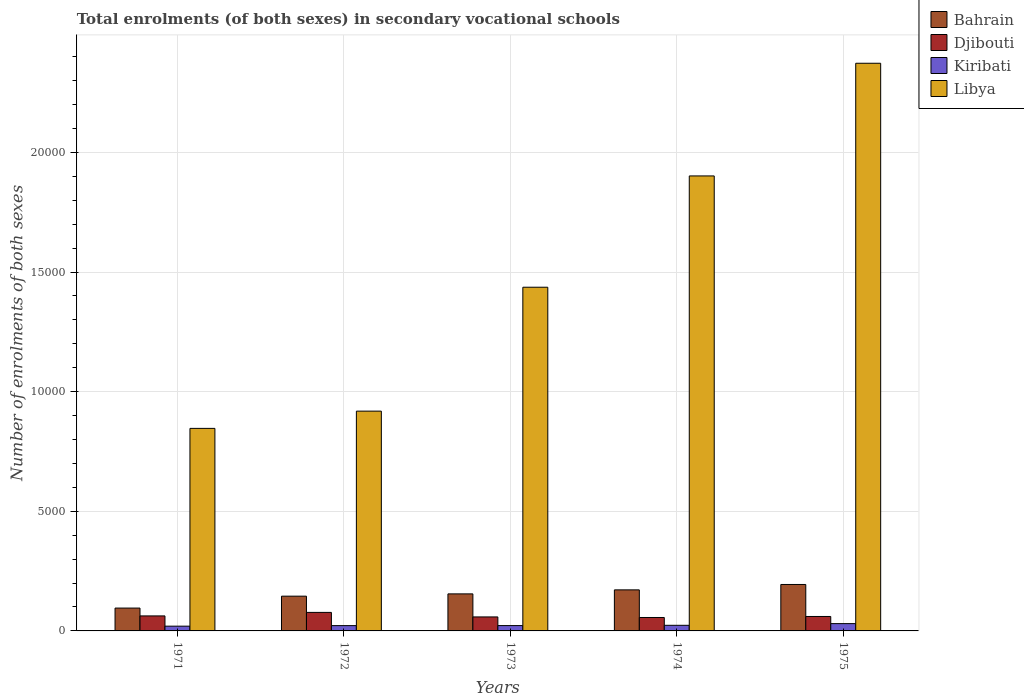How many groups of bars are there?
Provide a short and direct response. 5. Are the number of bars on each tick of the X-axis equal?
Make the answer very short. Yes. How many bars are there on the 4th tick from the right?
Provide a succinct answer. 4. What is the label of the 2nd group of bars from the left?
Provide a short and direct response. 1972. What is the number of enrolments in secondary schools in Djibouti in 1972?
Your response must be concise. 774. Across all years, what is the maximum number of enrolments in secondary schools in Bahrain?
Offer a very short reply. 1941. Across all years, what is the minimum number of enrolments in secondary schools in Djibouti?
Give a very brief answer. 561. In which year was the number of enrolments in secondary schools in Bahrain maximum?
Provide a succinct answer. 1975. In which year was the number of enrolments in secondary schools in Bahrain minimum?
Your answer should be very brief. 1971. What is the total number of enrolments in secondary schools in Libya in the graph?
Make the answer very short. 7.48e+04. What is the difference between the number of enrolments in secondary schools in Libya in 1972 and that in 1973?
Your response must be concise. -5179. What is the difference between the number of enrolments in secondary schools in Libya in 1975 and the number of enrolments in secondary schools in Kiribati in 1974?
Offer a terse response. 2.35e+04. What is the average number of enrolments in secondary schools in Kiribati per year?
Offer a very short reply. 236.8. In the year 1973, what is the difference between the number of enrolments in secondary schools in Djibouti and number of enrolments in secondary schools in Bahrain?
Offer a terse response. -963. What is the ratio of the number of enrolments in secondary schools in Kiribati in 1974 to that in 1975?
Provide a succinct answer. 0.77. Is the number of enrolments in secondary schools in Kiribati in 1971 less than that in 1972?
Provide a short and direct response. Yes. What is the difference between the highest and the second highest number of enrolments in secondary schools in Djibouti?
Your answer should be compact. 147. What is the difference between the highest and the lowest number of enrolments in secondary schools in Djibouti?
Provide a succinct answer. 213. Is it the case that in every year, the sum of the number of enrolments in secondary schools in Bahrain and number of enrolments in secondary schools in Libya is greater than the sum of number of enrolments in secondary schools in Kiribati and number of enrolments in secondary schools in Djibouti?
Provide a succinct answer. Yes. What does the 4th bar from the left in 1973 represents?
Provide a succinct answer. Libya. What does the 2nd bar from the right in 1973 represents?
Make the answer very short. Kiribati. How many bars are there?
Keep it short and to the point. 20. How many years are there in the graph?
Offer a terse response. 5. Are the values on the major ticks of Y-axis written in scientific E-notation?
Give a very brief answer. No. Does the graph contain grids?
Ensure brevity in your answer.  Yes. How many legend labels are there?
Offer a terse response. 4. What is the title of the graph?
Give a very brief answer. Total enrolments (of both sexes) in secondary vocational schools. What is the label or title of the Y-axis?
Provide a succinct answer. Number of enrolments of both sexes. What is the Number of enrolments of both sexes of Bahrain in 1971?
Ensure brevity in your answer.  955. What is the Number of enrolments of both sexes of Djibouti in 1971?
Make the answer very short. 627. What is the Number of enrolments of both sexes of Kiribati in 1971?
Keep it short and to the point. 199. What is the Number of enrolments of both sexes in Libya in 1971?
Offer a very short reply. 8465. What is the Number of enrolments of both sexes of Bahrain in 1972?
Your answer should be very brief. 1453. What is the Number of enrolments of both sexes of Djibouti in 1972?
Provide a short and direct response. 774. What is the Number of enrolments of both sexes in Kiribati in 1972?
Your answer should be compact. 222. What is the Number of enrolments of both sexes in Libya in 1972?
Offer a very short reply. 9186. What is the Number of enrolments of both sexes in Bahrain in 1973?
Your answer should be compact. 1548. What is the Number of enrolments of both sexes of Djibouti in 1973?
Your response must be concise. 585. What is the Number of enrolments of both sexes of Kiribati in 1973?
Give a very brief answer. 223. What is the Number of enrolments of both sexes of Libya in 1973?
Keep it short and to the point. 1.44e+04. What is the Number of enrolments of both sexes in Bahrain in 1974?
Your answer should be very brief. 1716. What is the Number of enrolments of both sexes of Djibouti in 1974?
Offer a terse response. 561. What is the Number of enrolments of both sexes of Kiribati in 1974?
Offer a very short reply. 235. What is the Number of enrolments of both sexes in Libya in 1974?
Offer a very short reply. 1.90e+04. What is the Number of enrolments of both sexes in Bahrain in 1975?
Your answer should be compact. 1941. What is the Number of enrolments of both sexes in Djibouti in 1975?
Make the answer very short. 604. What is the Number of enrolments of both sexes in Kiribati in 1975?
Make the answer very short. 305. What is the Number of enrolments of both sexes of Libya in 1975?
Make the answer very short. 2.37e+04. Across all years, what is the maximum Number of enrolments of both sexes of Bahrain?
Your answer should be compact. 1941. Across all years, what is the maximum Number of enrolments of both sexes in Djibouti?
Offer a very short reply. 774. Across all years, what is the maximum Number of enrolments of both sexes of Kiribati?
Your answer should be compact. 305. Across all years, what is the maximum Number of enrolments of both sexes in Libya?
Keep it short and to the point. 2.37e+04. Across all years, what is the minimum Number of enrolments of both sexes of Bahrain?
Provide a short and direct response. 955. Across all years, what is the minimum Number of enrolments of both sexes of Djibouti?
Keep it short and to the point. 561. Across all years, what is the minimum Number of enrolments of both sexes of Kiribati?
Your response must be concise. 199. Across all years, what is the minimum Number of enrolments of both sexes in Libya?
Provide a succinct answer. 8465. What is the total Number of enrolments of both sexes in Bahrain in the graph?
Your response must be concise. 7613. What is the total Number of enrolments of both sexes of Djibouti in the graph?
Ensure brevity in your answer.  3151. What is the total Number of enrolments of both sexes of Kiribati in the graph?
Your answer should be compact. 1184. What is the total Number of enrolments of both sexes of Libya in the graph?
Your answer should be compact. 7.48e+04. What is the difference between the Number of enrolments of both sexes of Bahrain in 1971 and that in 1972?
Ensure brevity in your answer.  -498. What is the difference between the Number of enrolments of both sexes in Djibouti in 1971 and that in 1972?
Provide a short and direct response. -147. What is the difference between the Number of enrolments of both sexes in Libya in 1971 and that in 1972?
Your answer should be very brief. -721. What is the difference between the Number of enrolments of both sexes in Bahrain in 1971 and that in 1973?
Your answer should be very brief. -593. What is the difference between the Number of enrolments of both sexes of Djibouti in 1971 and that in 1973?
Ensure brevity in your answer.  42. What is the difference between the Number of enrolments of both sexes in Kiribati in 1971 and that in 1973?
Provide a succinct answer. -24. What is the difference between the Number of enrolments of both sexes in Libya in 1971 and that in 1973?
Offer a very short reply. -5900. What is the difference between the Number of enrolments of both sexes in Bahrain in 1971 and that in 1974?
Offer a very short reply. -761. What is the difference between the Number of enrolments of both sexes in Kiribati in 1971 and that in 1974?
Give a very brief answer. -36. What is the difference between the Number of enrolments of both sexes of Libya in 1971 and that in 1974?
Your answer should be very brief. -1.06e+04. What is the difference between the Number of enrolments of both sexes in Bahrain in 1971 and that in 1975?
Your answer should be compact. -986. What is the difference between the Number of enrolments of both sexes of Djibouti in 1971 and that in 1975?
Make the answer very short. 23. What is the difference between the Number of enrolments of both sexes in Kiribati in 1971 and that in 1975?
Provide a short and direct response. -106. What is the difference between the Number of enrolments of both sexes in Libya in 1971 and that in 1975?
Offer a terse response. -1.53e+04. What is the difference between the Number of enrolments of both sexes of Bahrain in 1972 and that in 1973?
Your answer should be very brief. -95. What is the difference between the Number of enrolments of both sexes in Djibouti in 1972 and that in 1973?
Keep it short and to the point. 189. What is the difference between the Number of enrolments of both sexes of Libya in 1972 and that in 1973?
Keep it short and to the point. -5179. What is the difference between the Number of enrolments of both sexes in Bahrain in 1972 and that in 1974?
Offer a terse response. -263. What is the difference between the Number of enrolments of both sexes of Djibouti in 1972 and that in 1974?
Ensure brevity in your answer.  213. What is the difference between the Number of enrolments of both sexes of Libya in 1972 and that in 1974?
Give a very brief answer. -9831. What is the difference between the Number of enrolments of both sexes in Bahrain in 1972 and that in 1975?
Make the answer very short. -488. What is the difference between the Number of enrolments of both sexes of Djibouti in 1972 and that in 1975?
Make the answer very short. 170. What is the difference between the Number of enrolments of both sexes of Kiribati in 1972 and that in 1975?
Ensure brevity in your answer.  -83. What is the difference between the Number of enrolments of both sexes of Libya in 1972 and that in 1975?
Provide a short and direct response. -1.45e+04. What is the difference between the Number of enrolments of both sexes in Bahrain in 1973 and that in 1974?
Provide a succinct answer. -168. What is the difference between the Number of enrolments of both sexes in Libya in 1973 and that in 1974?
Your response must be concise. -4652. What is the difference between the Number of enrolments of both sexes in Bahrain in 1973 and that in 1975?
Offer a terse response. -393. What is the difference between the Number of enrolments of both sexes in Kiribati in 1973 and that in 1975?
Offer a terse response. -82. What is the difference between the Number of enrolments of both sexes in Libya in 1973 and that in 1975?
Give a very brief answer. -9361. What is the difference between the Number of enrolments of both sexes in Bahrain in 1974 and that in 1975?
Offer a terse response. -225. What is the difference between the Number of enrolments of both sexes in Djibouti in 1974 and that in 1975?
Your answer should be very brief. -43. What is the difference between the Number of enrolments of both sexes in Kiribati in 1974 and that in 1975?
Keep it short and to the point. -70. What is the difference between the Number of enrolments of both sexes of Libya in 1974 and that in 1975?
Provide a succinct answer. -4709. What is the difference between the Number of enrolments of both sexes of Bahrain in 1971 and the Number of enrolments of both sexes of Djibouti in 1972?
Provide a short and direct response. 181. What is the difference between the Number of enrolments of both sexes in Bahrain in 1971 and the Number of enrolments of both sexes in Kiribati in 1972?
Offer a terse response. 733. What is the difference between the Number of enrolments of both sexes of Bahrain in 1971 and the Number of enrolments of both sexes of Libya in 1972?
Your answer should be very brief. -8231. What is the difference between the Number of enrolments of both sexes in Djibouti in 1971 and the Number of enrolments of both sexes in Kiribati in 1972?
Your answer should be compact. 405. What is the difference between the Number of enrolments of both sexes in Djibouti in 1971 and the Number of enrolments of both sexes in Libya in 1972?
Keep it short and to the point. -8559. What is the difference between the Number of enrolments of both sexes in Kiribati in 1971 and the Number of enrolments of both sexes in Libya in 1972?
Your response must be concise. -8987. What is the difference between the Number of enrolments of both sexes of Bahrain in 1971 and the Number of enrolments of both sexes of Djibouti in 1973?
Your response must be concise. 370. What is the difference between the Number of enrolments of both sexes in Bahrain in 1971 and the Number of enrolments of both sexes in Kiribati in 1973?
Your answer should be compact. 732. What is the difference between the Number of enrolments of both sexes of Bahrain in 1971 and the Number of enrolments of both sexes of Libya in 1973?
Your response must be concise. -1.34e+04. What is the difference between the Number of enrolments of both sexes in Djibouti in 1971 and the Number of enrolments of both sexes in Kiribati in 1973?
Your answer should be very brief. 404. What is the difference between the Number of enrolments of both sexes of Djibouti in 1971 and the Number of enrolments of both sexes of Libya in 1973?
Make the answer very short. -1.37e+04. What is the difference between the Number of enrolments of both sexes in Kiribati in 1971 and the Number of enrolments of both sexes in Libya in 1973?
Make the answer very short. -1.42e+04. What is the difference between the Number of enrolments of both sexes of Bahrain in 1971 and the Number of enrolments of both sexes of Djibouti in 1974?
Provide a short and direct response. 394. What is the difference between the Number of enrolments of both sexes in Bahrain in 1971 and the Number of enrolments of both sexes in Kiribati in 1974?
Your response must be concise. 720. What is the difference between the Number of enrolments of both sexes in Bahrain in 1971 and the Number of enrolments of both sexes in Libya in 1974?
Offer a terse response. -1.81e+04. What is the difference between the Number of enrolments of both sexes in Djibouti in 1971 and the Number of enrolments of both sexes in Kiribati in 1974?
Your answer should be very brief. 392. What is the difference between the Number of enrolments of both sexes in Djibouti in 1971 and the Number of enrolments of both sexes in Libya in 1974?
Keep it short and to the point. -1.84e+04. What is the difference between the Number of enrolments of both sexes in Kiribati in 1971 and the Number of enrolments of both sexes in Libya in 1974?
Your answer should be very brief. -1.88e+04. What is the difference between the Number of enrolments of both sexes of Bahrain in 1971 and the Number of enrolments of both sexes of Djibouti in 1975?
Ensure brevity in your answer.  351. What is the difference between the Number of enrolments of both sexes of Bahrain in 1971 and the Number of enrolments of both sexes of Kiribati in 1975?
Offer a terse response. 650. What is the difference between the Number of enrolments of both sexes in Bahrain in 1971 and the Number of enrolments of both sexes in Libya in 1975?
Provide a succinct answer. -2.28e+04. What is the difference between the Number of enrolments of both sexes in Djibouti in 1971 and the Number of enrolments of both sexes in Kiribati in 1975?
Provide a short and direct response. 322. What is the difference between the Number of enrolments of both sexes of Djibouti in 1971 and the Number of enrolments of both sexes of Libya in 1975?
Provide a succinct answer. -2.31e+04. What is the difference between the Number of enrolments of both sexes in Kiribati in 1971 and the Number of enrolments of both sexes in Libya in 1975?
Ensure brevity in your answer.  -2.35e+04. What is the difference between the Number of enrolments of both sexes in Bahrain in 1972 and the Number of enrolments of both sexes in Djibouti in 1973?
Provide a short and direct response. 868. What is the difference between the Number of enrolments of both sexes of Bahrain in 1972 and the Number of enrolments of both sexes of Kiribati in 1973?
Your response must be concise. 1230. What is the difference between the Number of enrolments of both sexes of Bahrain in 1972 and the Number of enrolments of both sexes of Libya in 1973?
Give a very brief answer. -1.29e+04. What is the difference between the Number of enrolments of both sexes of Djibouti in 1972 and the Number of enrolments of both sexes of Kiribati in 1973?
Offer a very short reply. 551. What is the difference between the Number of enrolments of both sexes in Djibouti in 1972 and the Number of enrolments of both sexes in Libya in 1973?
Provide a succinct answer. -1.36e+04. What is the difference between the Number of enrolments of both sexes in Kiribati in 1972 and the Number of enrolments of both sexes in Libya in 1973?
Your answer should be very brief. -1.41e+04. What is the difference between the Number of enrolments of both sexes of Bahrain in 1972 and the Number of enrolments of both sexes of Djibouti in 1974?
Give a very brief answer. 892. What is the difference between the Number of enrolments of both sexes in Bahrain in 1972 and the Number of enrolments of both sexes in Kiribati in 1974?
Keep it short and to the point. 1218. What is the difference between the Number of enrolments of both sexes in Bahrain in 1972 and the Number of enrolments of both sexes in Libya in 1974?
Keep it short and to the point. -1.76e+04. What is the difference between the Number of enrolments of both sexes of Djibouti in 1972 and the Number of enrolments of both sexes of Kiribati in 1974?
Your answer should be very brief. 539. What is the difference between the Number of enrolments of both sexes of Djibouti in 1972 and the Number of enrolments of both sexes of Libya in 1974?
Your answer should be very brief. -1.82e+04. What is the difference between the Number of enrolments of both sexes in Kiribati in 1972 and the Number of enrolments of both sexes in Libya in 1974?
Give a very brief answer. -1.88e+04. What is the difference between the Number of enrolments of both sexes of Bahrain in 1972 and the Number of enrolments of both sexes of Djibouti in 1975?
Make the answer very short. 849. What is the difference between the Number of enrolments of both sexes of Bahrain in 1972 and the Number of enrolments of both sexes of Kiribati in 1975?
Give a very brief answer. 1148. What is the difference between the Number of enrolments of both sexes of Bahrain in 1972 and the Number of enrolments of both sexes of Libya in 1975?
Your answer should be compact. -2.23e+04. What is the difference between the Number of enrolments of both sexes in Djibouti in 1972 and the Number of enrolments of both sexes in Kiribati in 1975?
Provide a succinct answer. 469. What is the difference between the Number of enrolments of both sexes in Djibouti in 1972 and the Number of enrolments of both sexes in Libya in 1975?
Your answer should be very brief. -2.30e+04. What is the difference between the Number of enrolments of both sexes in Kiribati in 1972 and the Number of enrolments of both sexes in Libya in 1975?
Your answer should be very brief. -2.35e+04. What is the difference between the Number of enrolments of both sexes of Bahrain in 1973 and the Number of enrolments of both sexes of Djibouti in 1974?
Keep it short and to the point. 987. What is the difference between the Number of enrolments of both sexes of Bahrain in 1973 and the Number of enrolments of both sexes of Kiribati in 1974?
Provide a succinct answer. 1313. What is the difference between the Number of enrolments of both sexes in Bahrain in 1973 and the Number of enrolments of both sexes in Libya in 1974?
Your answer should be very brief. -1.75e+04. What is the difference between the Number of enrolments of both sexes in Djibouti in 1973 and the Number of enrolments of both sexes in Kiribati in 1974?
Ensure brevity in your answer.  350. What is the difference between the Number of enrolments of both sexes in Djibouti in 1973 and the Number of enrolments of both sexes in Libya in 1974?
Keep it short and to the point. -1.84e+04. What is the difference between the Number of enrolments of both sexes of Kiribati in 1973 and the Number of enrolments of both sexes of Libya in 1974?
Your answer should be very brief. -1.88e+04. What is the difference between the Number of enrolments of both sexes in Bahrain in 1973 and the Number of enrolments of both sexes in Djibouti in 1975?
Give a very brief answer. 944. What is the difference between the Number of enrolments of both sexes in Bahrain in 1973 and the Number of enrolments of both sexes in Kiribati in 1975?
Your answer should be compact. 1243. What is the difference between the Number of enrolments of both sexes in Bahrain in 1973 and the Number of enrolments of both sexes in Libya in 1975?
Your answer should be very brief. -2.22e+04. What is the difference between the Number of enrolments of both sexes in Djibouti in 1973 and the Number of enrolments of both sexes in Kiribati in 1975?
Offer a terse response. 280. What is the difference between the Number of enrolments of both sexes in Djibouti in 1973 and the Number of enrolments of both sexes in Libya in 1975?
Provide a succinct answer. -2.31e+04. What is the difference between the Number of enrolments of both sexes of Kiribati in 1973 and the Number of enrolments of both sexes of Libya in 1975?
Offer a very short reply. -2.35e+04. What is the difference between the Number of enrolments of both sexes of Bahrain in 1974 and the Number of enrolments of both sexes of Djibouti in 1975?
Give a very brief answer. 1112. What is the difference between the Number of enrolments of both sexes of Bahrain in 1974 and the Number of enrolments of both sexes of Kiribati in 1975?
Keep it short and to the point. 1411. What is the difference between the Number of enrolments of both sexes of Bahrain in 1974 and the Number of enrolments of both sexes of Libya in 1975?
Make the answer very short. -2.20e+04. What is the difference between the Number of enrolments of both sexes of Djibouti in 1974 and the Number of enrolments of both sexes of Kiribati in 1975?
Provide a succinct answer. 256. What is the difference between the Number of enrolments of both sexes of Djibouti in 1974 and the Number of enrolments of both sexes of Libya in 1975?
Make the answer very short. -2.32e+04. What is the difference between the Number of enrolments of both sexes in Kiribati in 1974 and the Number of enrolments of both sexes in Libya in 1975?
Your answer should be very brief. -2.35e+04. What is the average Number of enrolments of both sexes of Bahrain per year?
Offer a terse response. 1522.6. What is the average Number of enrolments of both sexes in Djibouti per year?
Keep it short and to the point. 630.2. What is the average Number of enrolments of both sexes in Kiribati per year?
Ensure brevity in your answer.  236.8. What is the average Number of enrolments of both sexes of Libya per year?
Your answer should be very brief. 1.50e+04. In the year 1971, what is the difference between the Number of enrolments of both sexes in Bahrain and Number of enrolments of both sexes in Djibouti?
Make the answer very short. 328. In the year 1971, what is the difference between the Number of enrolments of both sexes in Bahrain and Number of enrolments of both sexes in Kiribati?
Keep it short and to the point. 756. In the year 1971, what is the difference between the Number of enrolments of both sexes of Bahrain and Number of enrolments of both sexes of Libya?
Offer a very short reply. -7510. In the year 1971, what is the difference between the Number of enrolments of both sexes in Djibouti and Number of enrolments of both sexes in Kiribati?
Provide a succinct answer. 428. In the year 1971, what is the difference between the Number of enrolments of both sexes of Djibouti and Number of enrolments of both sexes of Libya?
Keep it short and to the point. -7838. In the year 1971, what is the difference between the Number of enrolments of both sexes of Kiribati and Number of enrolments of both sexes of Libya?
Make the answer very short. -8266. In the year 1972, what is the difference between the Number of enrolments of both sexes of Bahrain and Number of enrolments of both sexes of Djibouti?
Provide a short and direct response. 679. In the year 1972, what is the difference between the Number of enrolments of both sexes of Bahrain and Number of enrolments of both sexes of Kiribati?
Your answer should be very brief. 1231. In the year 1972, what is the difference between the Number of enrolments of both sexes of Bahrain and Number of enrolments of both sexes of Libya?
Keep it short and to the point. -7733. In the year 1972, what is the difference between the Number of enrolments of both sexes in Djibouti and Number of enrolments of both sexes in Kiribati?
Ensure brevity in your answer.  552. In the year 1972, what is the difference between the Number of enrolments of both sexes in Djibouti and Number of enrolments of both sexes in Libya?
Your response must be concise. -8412. In the year 1972, what is the difference between the Number of enrolments of both sexes in Kiribati and Number of enrolments of both sexes in Libya?
Make the answer very short. -8964. In the year 1973, what is the difference between the Number of enrolments of both sexes of Bahrain and Number of enrolments of both sexes of Djibouti?
Ensure brevity in your answer.  963. In the year 1973, what is the difference between the Number of enrolments of both sexes of Bahrain and Number of enrolments of both sexes of Kiribati?
Provide a succinct answer. 1325. In the year 1973, what is the difference between the Number of enrolments of both sexes of Bahrain and Number of enrolments of both sexes of Libya?
Provide a succinct answer. -1.28e+04. In the year 1973, what is the difference between the Number of enrolments of both sexes in Djibouti and Number of enrolments of both sexes in Kiribati?
Offer a terse response. 362. In the year 1973, what is the difference between the Number of enrolments of both sexes in Djibouti and Number of enrolments of both sexes in Libya?
Your response must be concise. -1.38e+04. In the year 1973, what is the difference between the Number of enrolments of both sexes of Kiribati and Number of enrolments of both sexes of Libya?
Give a very brief answer. -1.41e+04. In the year 1974, what is the difference between the Number of enrolments of both sexes in Bahrain and Number of enrolments of both sexes in Djibouti?
Your answer should be compact. 1155. In the year 1974, what is the difference between the Number of enrolments of both sexes of Bahrain and Number of enrolments of both sexes of Kiribati?
Provide a short and direct response. 1481. In the year 1974, what is the difference between the Number of enrolments of both sexes of Bahrain and Number of enrolments of both sexes of Libya?
Give a very brief answer. -1.73e+04. In the year 1974, what is the difference between the Number of enrolments of both sexes of Djibouti and Number of enrolments of both sexes of Kiribati?
Offer a very short reply. 326. In the year 1974, what is the difference between the Number of enrolments of both sexes in Djibouti and Number of enrolments of both sexes in Libya?
Ensure brevity in your answer.  -1.85e+04. In the year 1974, what is the difference between the Number of enrolments of both sexes in Kiribati and Number of enrolments of both sexes in Libya?
Your answer should be very brief. -1.88e+04. In the year 1975, what is the difference between the Number of enrolments of both sexes in Bahrain and Number of enrolments of both sexes in Djibouti?
Provide a succinct answer. 1337. In the year 1975, what is the difference between the Number of enrolments of both sexes of Bahrain and Number of enrolments of both sexes of Kiribati?
Give a very brief answer. 1636. In the year 1975, what is the difference between the Number of enrolments of both sexes of Bahrain and Number of enrolments of both sexes of Libya?
Your response must be concise. -2.18e+04. In the year 1975, what is the difference between the Number of enrolments of both sexes of Djibouti and Number of enrolments of both sexes of Kiribati?
Provide a short and direct response. 299. In the year 1975, what is the difference between the Number of enrolments of both sexes of Djibouti and Number of enrolments of both sexes of Libya?
Your answer should be compact. -2.31e+04. In the year 1975, what is the difference between the Number of enrolments of both sexes of Kiribati and Number of enrolments of both sexes of Libya?
Give a very brief answer. -2.34e+04. What is the ratio of the Number of enrolments of both sexes in Bahrain in 1971 to that in 1972?
Your answer should be compact. 0.66. What is the ratio of the Number of enrolments of both sexes in Djibouti in 1971 to that in 1972?
Give a very brief answer. 0.81. What is the ratio of the Number of enrolments of both sexes in Kiribati in 1971 to that in 1972?
Offer a very short reply. 0.9. What is the ratio of the Number of enrolments of both sexes in Libya in 1971 to that in 1972?
Your answer should be very brief. 0.92. What is the ratio of the Number of enrolments of both sexes in Bahrain in 1971 to that in 1973?
Provide a short and direct response. 0.62. What is the ratio of the Number of enrolments of both sexes in Djibouti in 1971 to that in 1973?
Offer a very short reply. 1.07. What is the ratio of the Number of enrolments of both sexes of Kiribati in 1971 to that in 1973?
Ensure brevity in your answer.  0.89. What is the ratio of the Number of enrolments of both sexes in Libya in 1971 to that in 1973?
Offer a very short reply. 0.59. What is the ratio of the Number of enrolments of both sexes of Bahrain in 1971 to that in 1974?
Your response must be concise. 0.56. What is the ratio of the Number of enrolments of both sexes in Djibouti in 1971 to that in 1974?
Provide a short and direct response. 1.12. What is the ratio of the Number of enrolments of both sexes of Kiribati in 1971 to that in 1974?
Your answer should be compact. 0.85. What is the ratio of the Number of enrolments of both sexes in Libya in 1971 to that in 1974?
Your response must be concise. 0.45. What is the ratio of the Number of enrolments of both sexes in Bahrain in 1971 to that in 1975?
Your answer should be very brief. 0.49. What is the ratio of the Number of enrolments of both sexes of Djibouti in 1971 to that in 1975?
Offer a terse response. 1.04. What is the ratio of the Number of enrolments of both sexes of Kiribati in 1971 to that in 1975?
Your answer should be very brief. 0.65. What is the ratio of the Number of enrolments of both sexes in Libya in 1971 to that in 1975?
Offer a very short reply. 0.36. What is the ratio of the Number of enrolments of both sexes in Bahrain in 1972 to that in 1973?
Make the answer very short. 0.94. What is the ratio of the Number of enrolments of both sexes of Djibouti in 1972 to that in 1973?
Offer a terse response. 1.32. What is the ratio of the Number of enrolments of both sexes in Libya in 1972 to that in 1973?
Your answer should be compact. 0.64. What is the ratio of the Number of enrolments of both sexes of Bahrain in 1972 to that in 1974?
Keep it short and to the point. 0.85. What is the ratio of the Number of enrolments of both sexes of Djibouti in 1972 to that in 1974?
Give a very brief answer. 1.38. What is the ratio of the Number of enrolments of both sexes of Kiribati in 1972 to that in 1974?
Offer a very short reply. 0.94. What is the ratio of the Number of enrolments of both sexes of Libya in 1972 to that in 1974?
Make the answer very short. 0.48. What is the ratio of the Number of enrolments of both sexes of Bahrain in 1972 to that in 1975?
Ensure brevity in your answer.  0.75. What is the ratio of the Number of enrolments of both sexes in Djibouti in 1972 to that in 1975?
Your answer should be compact. 1.28. What is the ratio of the Number of enrolments of both sexes of Kiribati in 1972 to that in 1975?
Your answer should be compact. 0.73. What is the ratio of the Number of enrolments of both sexes in Libya in 1972 to that in 1975?
Your answer should be compact. 0.39. What is the ratio of the Number of enrolments of both sexes of Bahrain in 1973 to that in 1974?
Your answer should be compact. 0.9. What is the ratio of the Number of enrolments of both sexes of Djibouti in 1973 to that in 1974?
Make the answer very short. 1.04. What is the ratio of the Number of enrolments of both sexes of Kiribati in 1973 to that in 1974?
Give a very brief answer. 0.95. What is the ratio of the Number of enrolments of both sexes of Libya in 1973 to that in 1974?
Offer a very short reply. 0.76. What is the ratio of the Number of enrolments of both sexes in Bahrain in 1973 to that in 1975?
Ensure brevity in your answer.  0.8. What is the ratio of the Number of enrolments of both sexes of Djibouti in 1973 to that in 1975?
Offer a very short reply. 0.97. What is the ratio of the Number of enrolments of both sexes of Kiribati in 1973 to that in 1975?
Your answer should be very brief. 0.73. What is the ratio of the Number of enrolments of both sexes in Libya in 1973 to that in 1975?
Provide a short and direct response. 0.61. What is the ratio of the Number of enrolments of both sexes in Bahrain in 1974 to that in 1975?
Offer a very short reply. 0.88. What is the ratio of the Number of enrolments of both sexes of Djibouti in 1974 to that in 1975?
Give a very brief answer. 0.93. What is the ratio of the Number of enrolments of both sexes in Kiribati in 1974 to that in 1975?
Your response must be concise. 0.77. What is the ratio of the Number of enrolments of both sexes of Libya in 1974 to that in 1975?
Ensure brevity in your answer.  0.8. What is the difference between the highest and the second highest Number of enrolments of both sexes of Bahrain?
Provide a short and direct response. 225. What is the difference between the highest and the second highest Number of enrolments of both sexes in Djibouti?
Ensure brevity in your answer.  147. What is the difference between the highest and the second highest Number of enrolments of both sexes of Libya?
Provide a short and direct response. 4709. What is the difference between the highest and the lowest Number of enrolments of both sexes of Bahrain?
Your answer should be very brief. 986. What is the difference between the highest and the lowest Number of enrolments of both sexes of Djibouti?
Provide a short and direct response. 213. What is the difference between the highest and the lowest Number of enrolments of both sexes in Kiribati?
Your response must be concise. 106. What is the difference between the highest and the lowest Number of enrolments of both sexes in Libya?
Your response must be concise. 1.53e+04. 